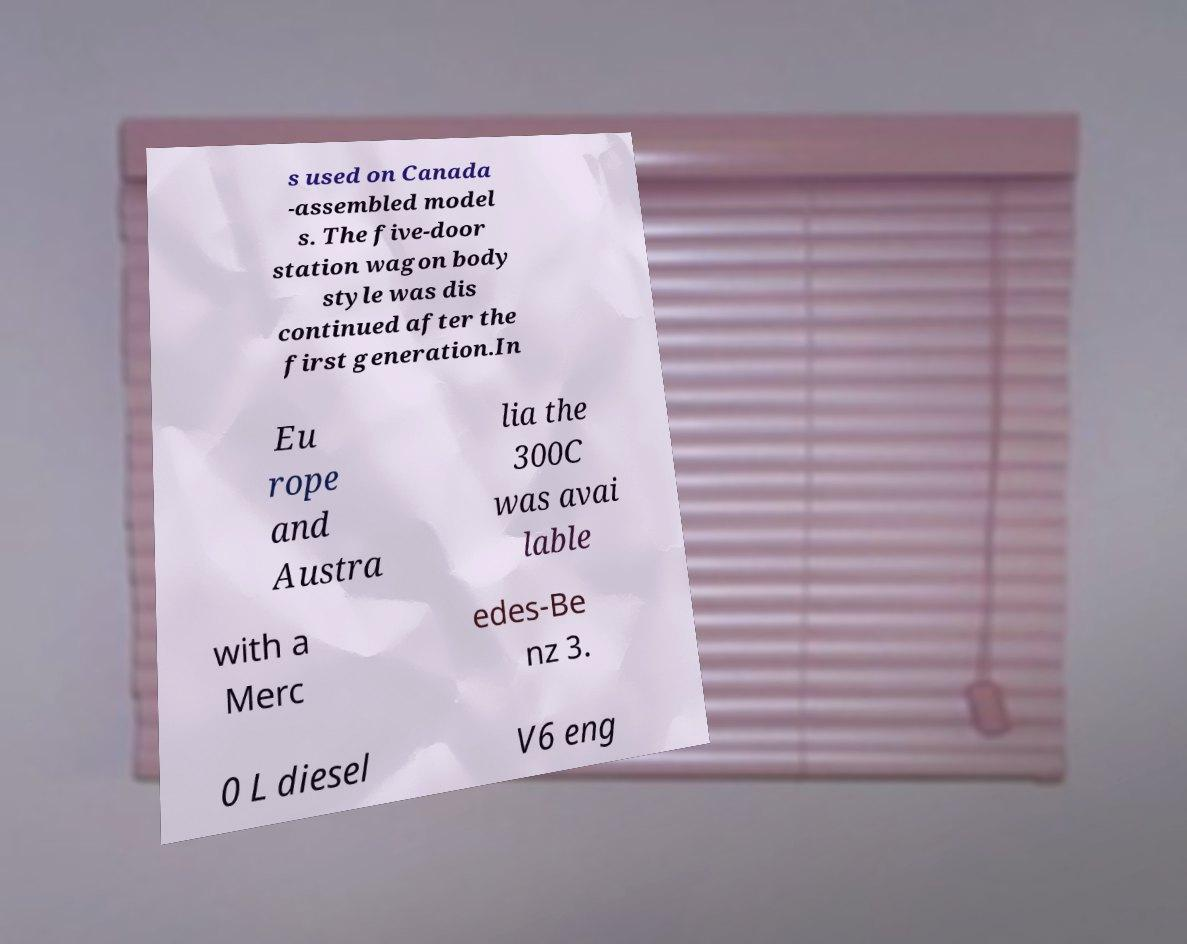For documentation purposes, I need the text within this image transcribed. Could you provide that? s used on Canada -assembled model s. The five-door station wagon body style was dis continued after the first generation.In Eu rope and Austra lia the 300C was avai lable with a Merc edes-Be nz 3. 0 L diesel V6 eng 